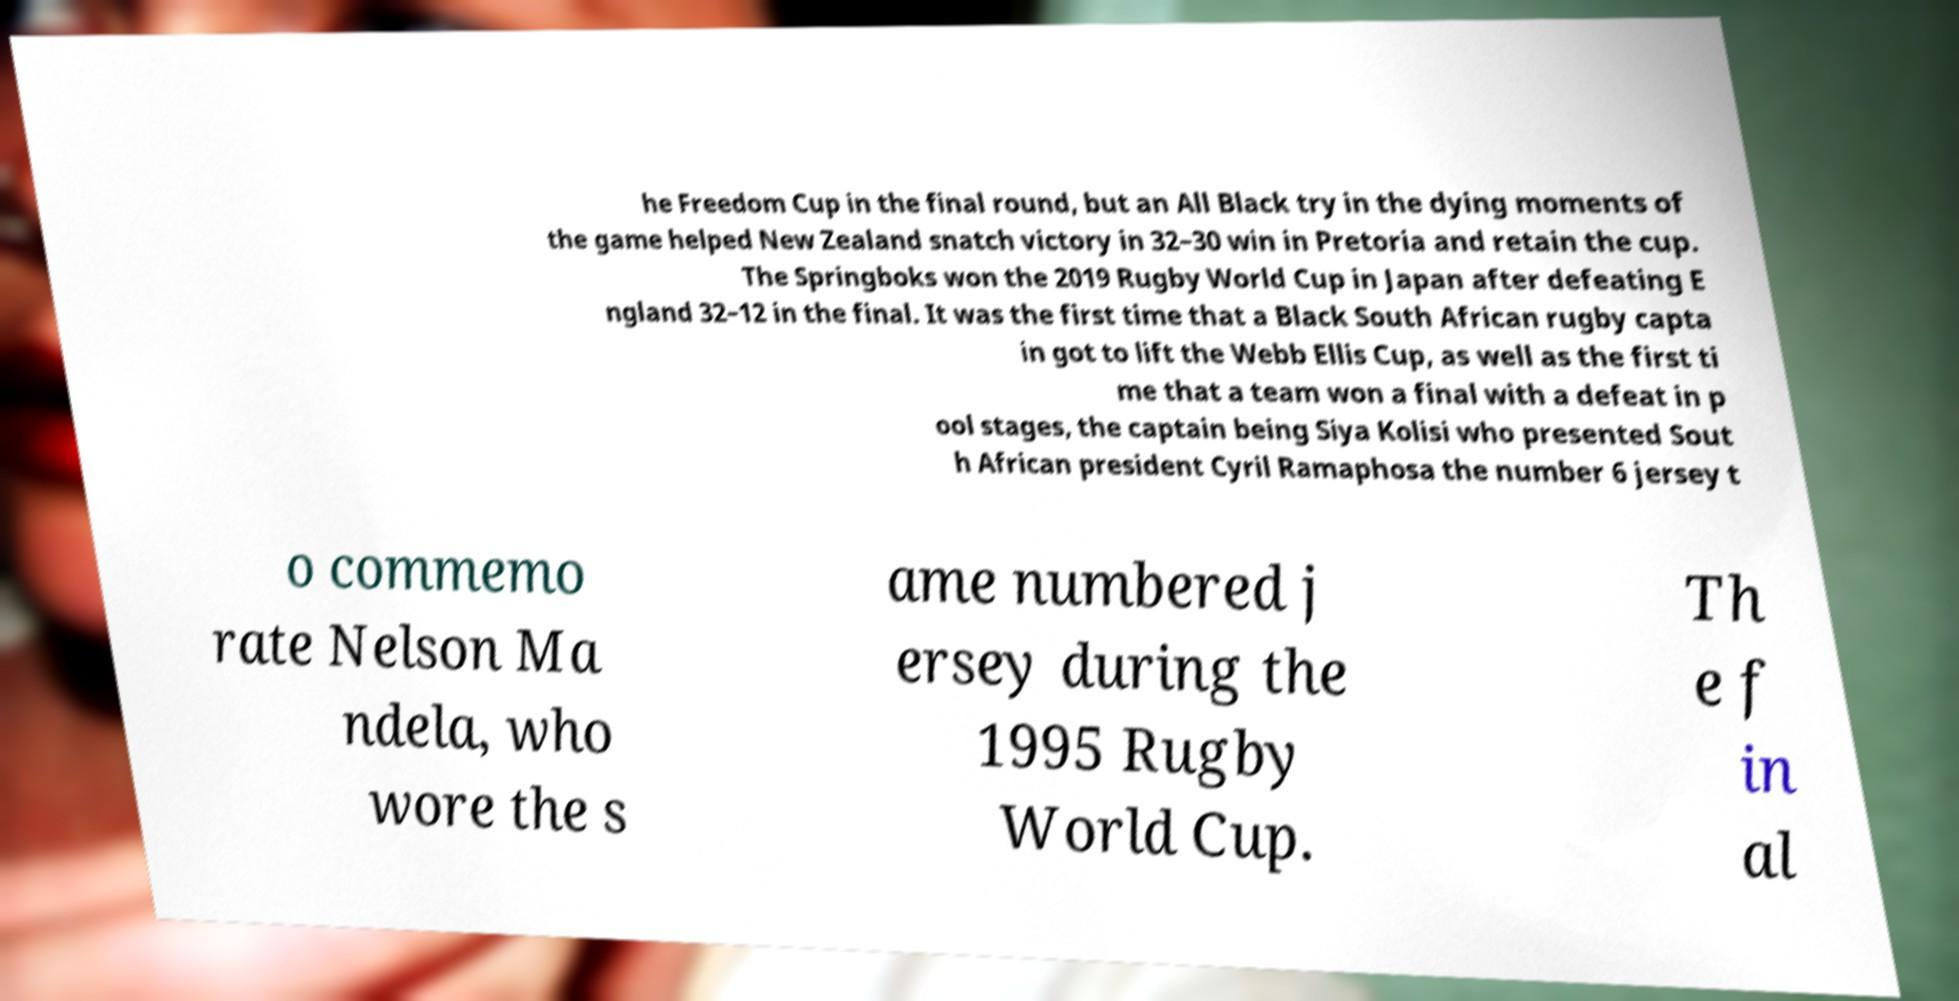What messages or text are displayed in this image? I need them in a readable, typed format. he Freedom Cup in the final round, but an All Black try in the dying moments of the game helped New Zealand snatch victory in 32–30 win in Pretoria and retain the cup. The Springboks won the 2019 Rugby World Cup in Japan after defeating E ngland 32–12 in the final. It was the first time that a Black South African rugby capta in got to lift the Webb Ellis Cup, as well as the first ti me that a team won a final with a defeat in p ool stages, the captain being Siya Kolisi who presented Sout h African president Cyril Ramaphosa the number 6 jersey t o commemo rate Nelson Ma ndela, who wore the s ame numbered j ersey during the 1995 Rugby World Cup. Th e f in al 